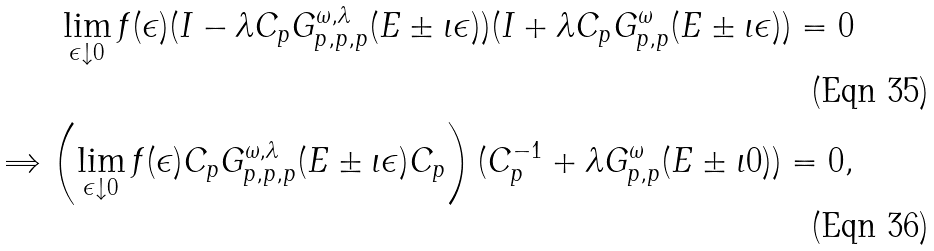Convert formula to latex. <formula><loc_0><loc_0><loc_500><loc_500>\lim _ { \epsilon \downarrow 0 } f ( \epsilon ) ( I - \lambda C _ { p } G ^ { \omega , \lambda } _ { p , p , p } ( E \pm \iota \epsilon ) ) ( I + \lambda C _ { p } G ^ { \omega } _ { p , p } ( E \pm \iota \epsilon ) ) = 0 \\ \Rightarrow \left ( \lim _ { \epsilon \downarrow 0 } f ( \epsilon ) C _ { p } G ^ { \omega , \lambda } _ { p , p , p } ( E \pm \iota \epsilon ) C _ { p } \right ) ( C _ { p } ^ { - 1 } + \lambda G ^ { \omega } _ { p , p } ( E \pm \iota 0 ) ) = 0 ,</formula> 